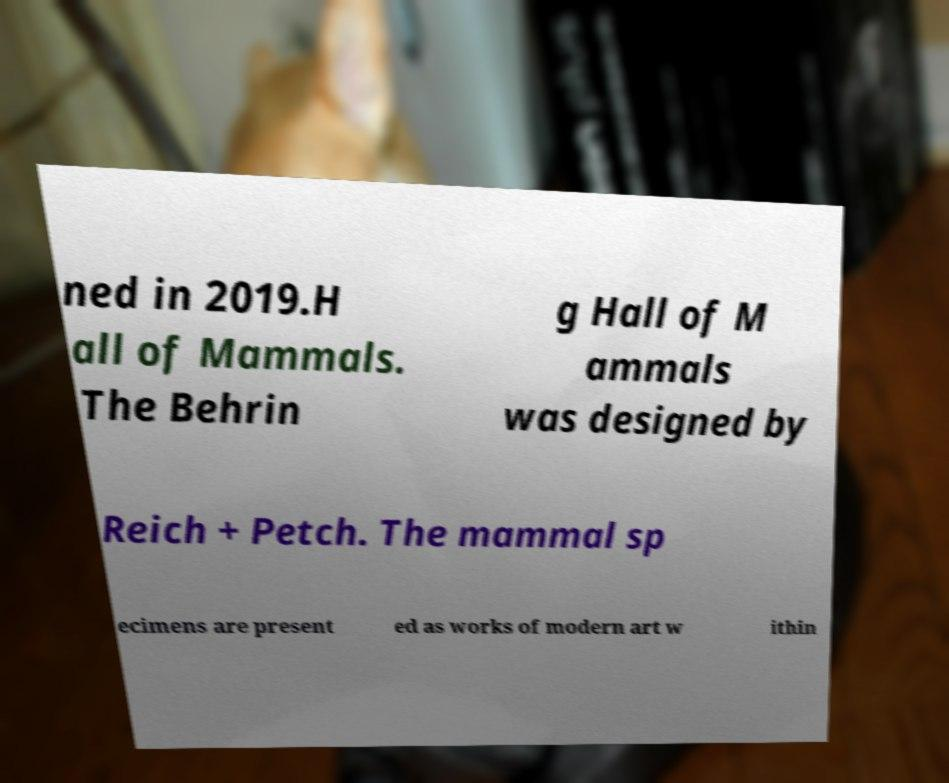Can you accurately transcribe the text from the provided image for me? ned in 2019.H all of Mammals. The Behrin g Hall of M ammals was designed by Reich + Petch. The mammal sp ecimens are present ed as works of modern art w ithin 